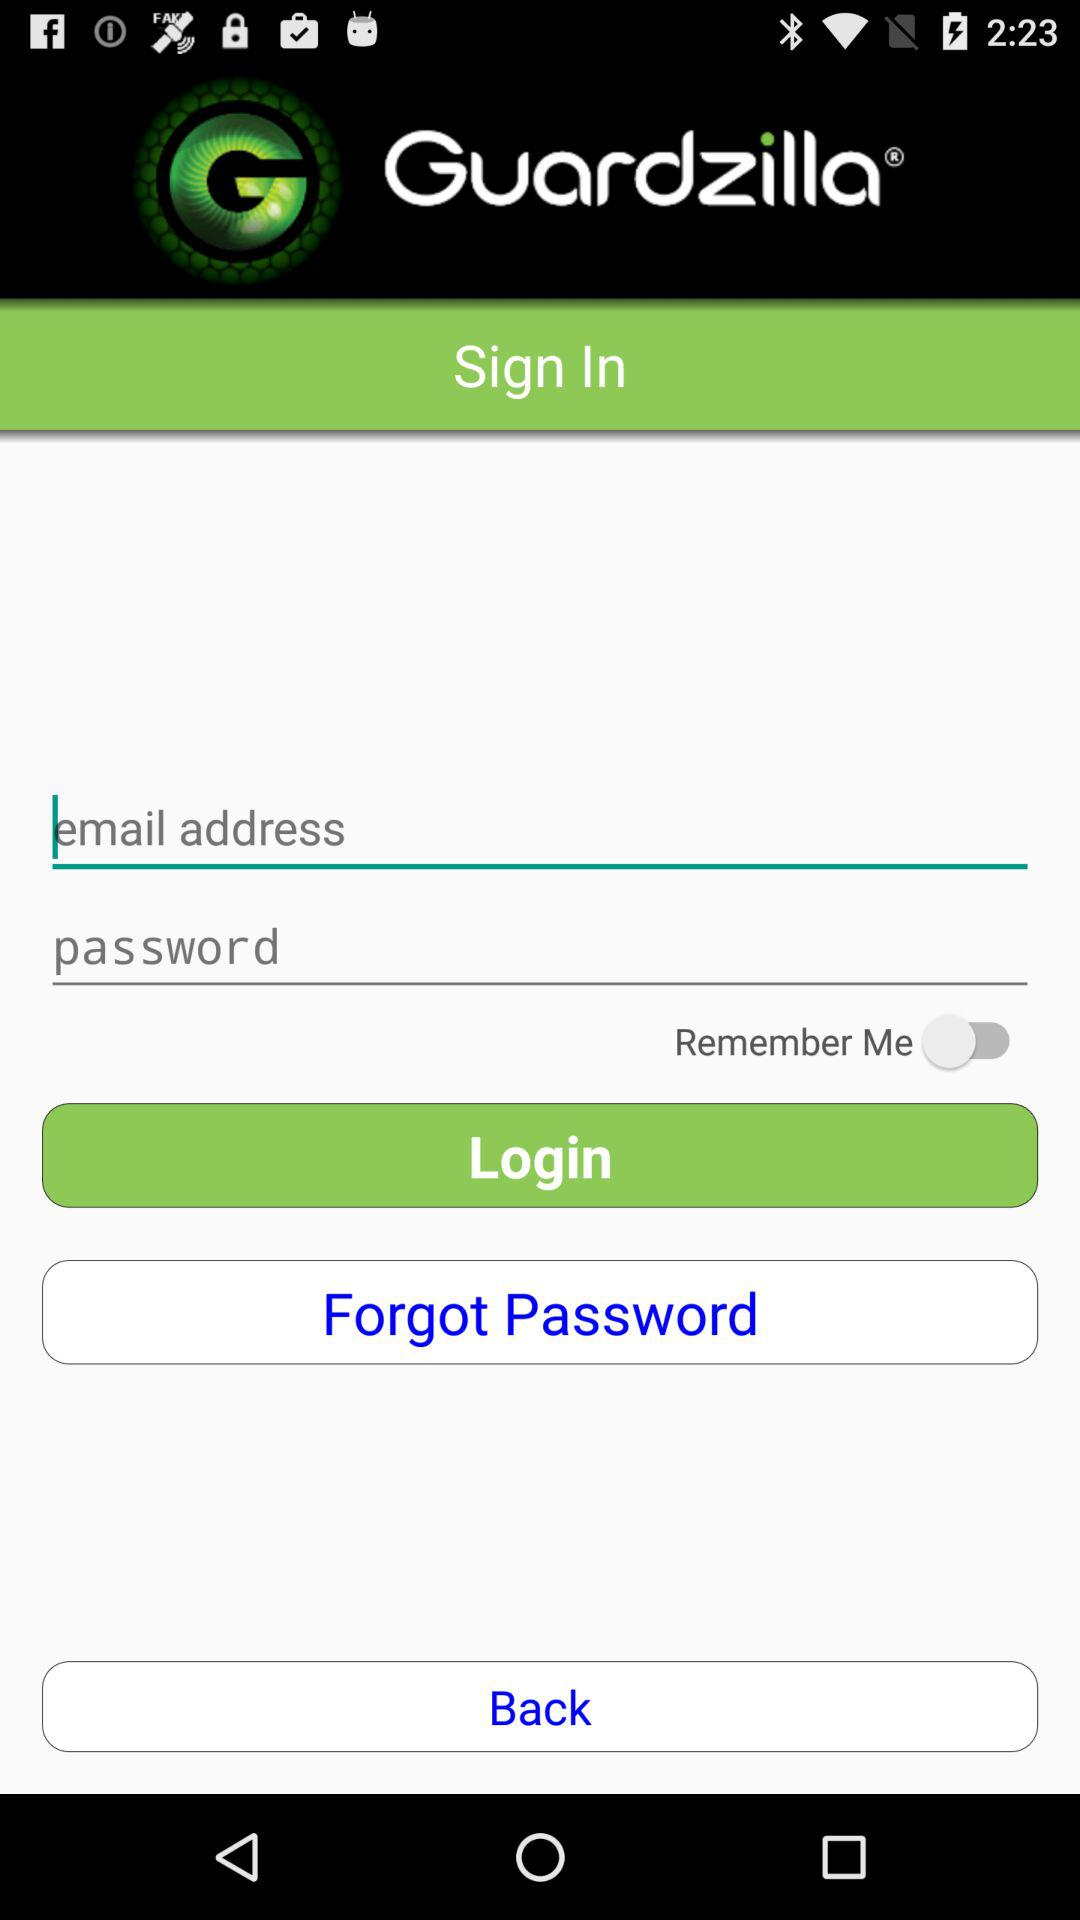What is the name of the application? The name of the application is "Guardzilla". 